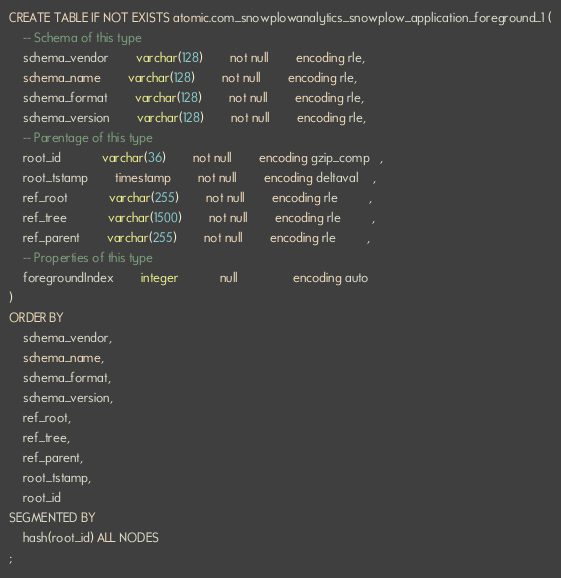Convert code to text. <code><loc_0><loc_0><loc_500><loc_500><_SQL_>CREATE TABLE IF NOT EXISTS atomic.com_snowplowanalytics_snowplow_application_foreground_1 (
	-- Schema of this type
	schema_vendor		varchar(128)		not null		encoding rle,
	schema_name 		varchar(128)		not null		encoding rle,
	schema_format		varchar(128)		not null		encoding rle,
	schema_version		varchar(128)		not null		encoding rle,
	-- Parentage of this type
	root_id     		varchar(36) 		not null		encoding gzip_comp   ,
	root_tstamp 		timestamp   		not null		encoding deltaval    ,
	ref_root    		varchar(255)		not null		encoding rle         ,
	ref_tree    		varchar(1500)		not null		encoding rle         ,
	ref_parent  		varchar(255)		not null		encoding rle         ,
	-- Properties of this type
	foregroundIndex		integer     		null        		encoding auto        
)
ORDER BY
	schema_vendor,
	schema_name,
	schema_format,
	schema_version,
	ref_root,
	ref_tree,
	ref_parent,
	root_tstamp,
	root_id
SEGMENTED BY
	hash(root_id) ALL NODES
;</code> 